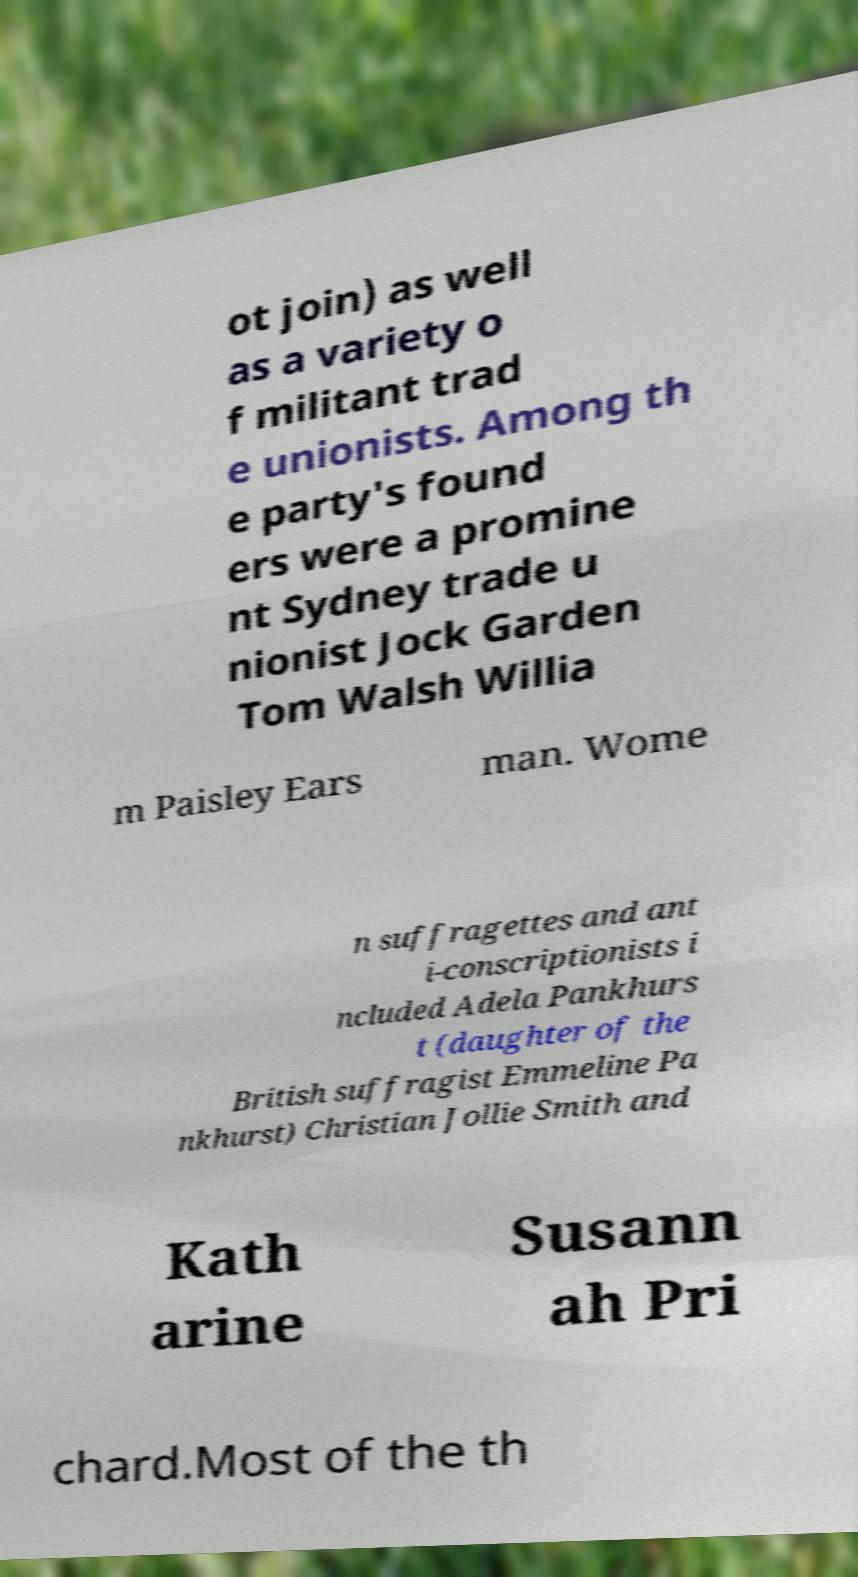I need the written content from this picture converted into text. Can you do that? ot join) as well as a variety o f militant trad e unionists. Among th e party's found ers were a promine nt Sydney trade u nionist Jock Garden Tom Walsh Willia m Paisley Ears man. Wome n suffragettes and ant i-conscriptionists i ncluded Adela Pankhurs t (daughter of the British suffragist Emmeline Pa nkhurst) Christian Jollie Smith and Kath arine Susann ah Pri chard.Most of the th 